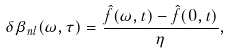Convert formula to latex. <formula><loc_0><loc_0><loc_500><loc_500>\delta \beta _ { n l } ( \omega , \tau ) = \frac { \hat { f } ( \omega , t ) - \hat { f } ( 0 , t ) } \eta ,</formula> 